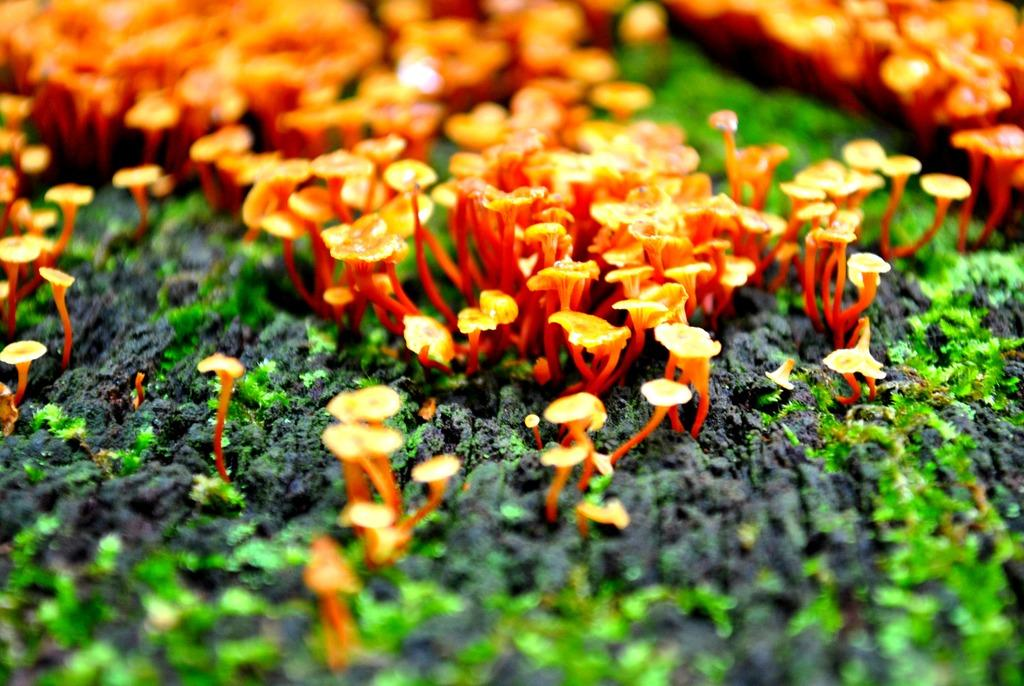What type of living organisms are present in the image? There are small plants in the image. Can you describe the background of the image? The background of the image is blurred. Did the earthquake cause the plants to fall over in the image? There is no indication of an earthquake or any fallen plants in the image. 